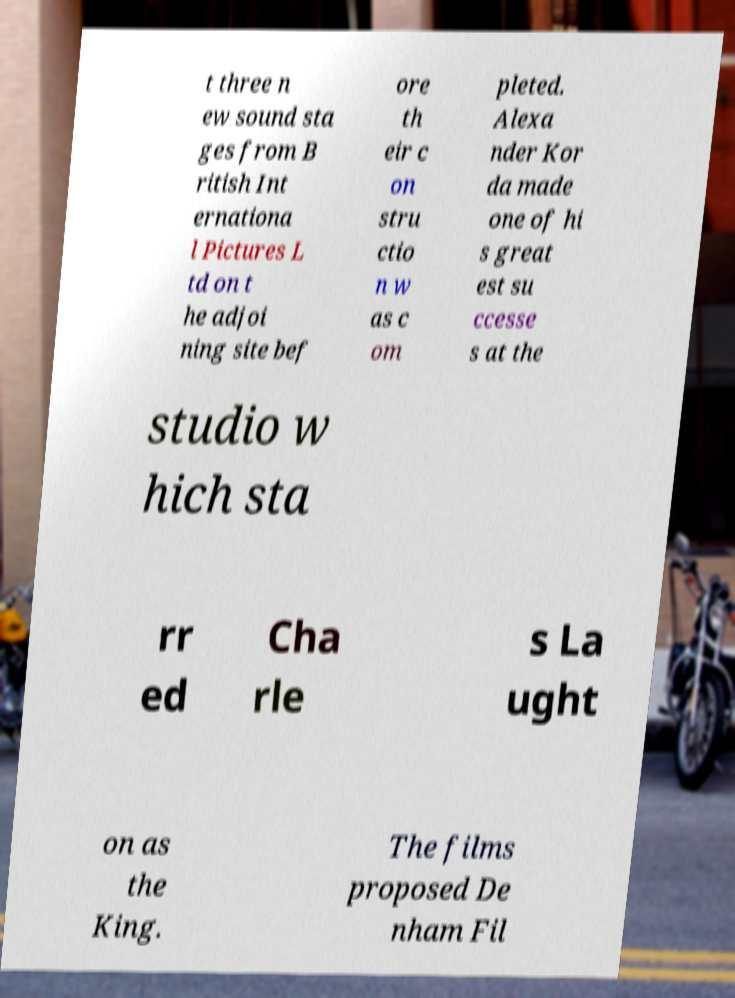Can you read and provide the text displayed in the image?This photo seems to have some interesting text. Can you extract and type it out for me? t three n ew sound sta ges from B ritish Int ernationa l Pictures L td on t he adjoi ning site bef ore th eir c on stru ctio n w as c om pleted. Alexa nder Kor da made one of hi s great est su ccesse s at the studio w hich sta rr ed Cha rle s La ught on as the King. The films proposed De nham Fil 